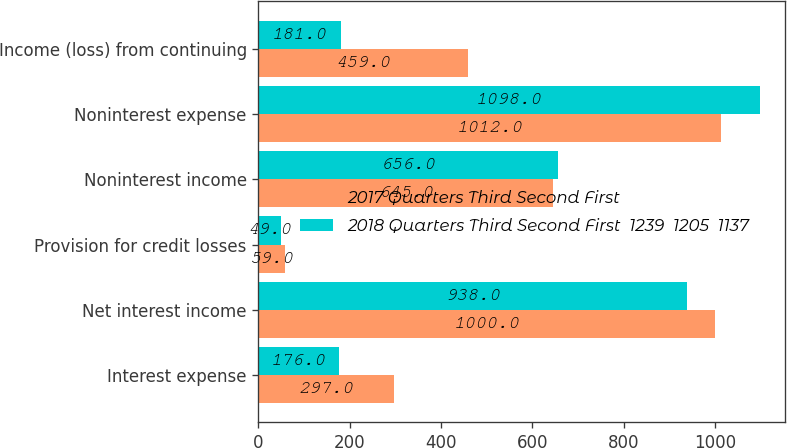Convert chart. <chart><loc_0><loc_0><loc_500><loc_500><stacked_bar_chart><ecel><fcel>Interest expense<fcel>Net interest income<fcel>Provision for credit losses<fcel>Noninterest income<fcel>Noninterest expense<fcel>Income (loss) from continuing<nl><fcel>2017 Quarters Third Second First<fcel>297<fcel>1000<fcel>59<fcel>645<fcel>1012<fcel>459<nl><fcel>2018 Quarters Third Second First  1239  1205  1137<fcel>176<fcel>938<fcel>49<fcel>656<fcel>1098<fcel>181<nl></chart> 